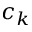<formula> <loc_0><loc_0><loc_500><loc_500>c _ { k }</formula> 